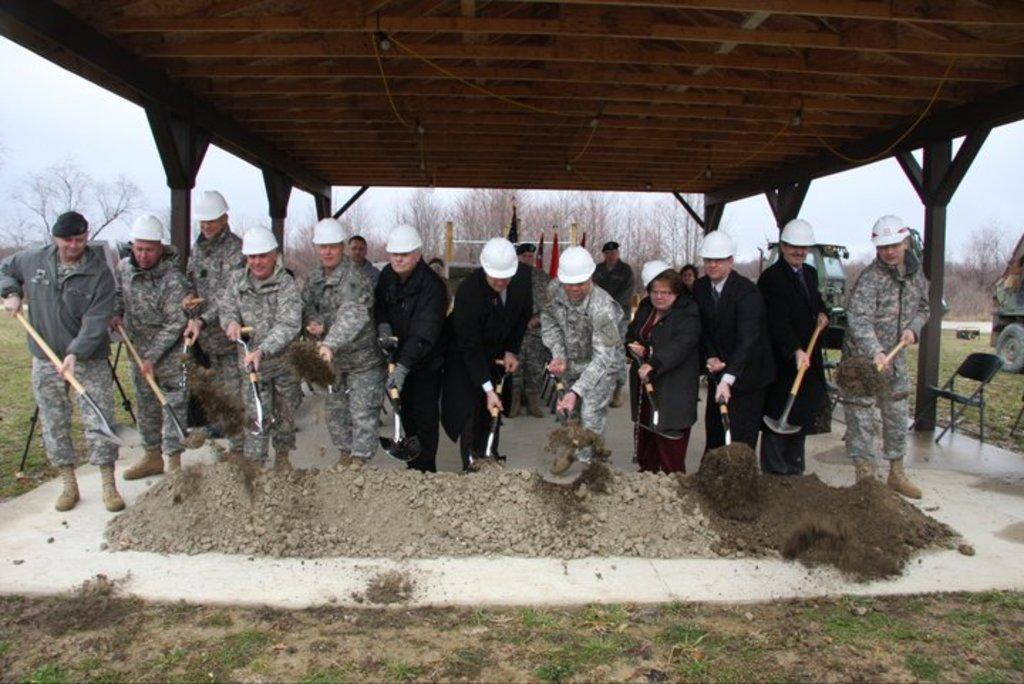Describe this image in one or two sentences. In this image there are a few people standing beneath the shed and they are holding objects in their hand and digging the sand, behind them there are flags and trees. On the right side of the image there is a chair and vehicles. In the background there is the sky. 